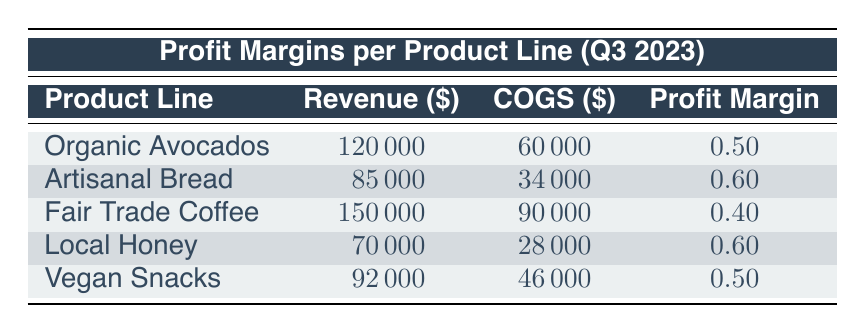What is the Profit Margin for Local Honey? The table shows that the Profit Margin for Local Honey is listed in the Profit Margin column next to its revenue and COGS data. It is 0.60.
Answer: 0.60 Which product line has the highest Revenue? Looking at the Revenue column, Fair Trade Coffee has the highest value of 150000, compared to others.
Answer: Fair Trade Coffee What is the combined Revenue of Organic Avocados and Artisanal Bread? To find the combined Revenue of Organic Avocados (120000) and Artisanal Bread (85000), add these amounts together: 120000 + 85000 = 205000.
Answer: 205000 Is the Profit Margin for Vegan Snacks greater than that of Fair Trade Coffee? The Profit Margin for Vegan Snacks is 0.50, while for Fair Trade Coffee it is 0.40. Since 0.50 is greater than 0.40, the answer is yes.
Answer: Yes What is the average Profit Margin for all product lines combined? To calculate the average Profit Margin, sum the Profit Margins for all products: (0.50 + 0.60 + 0.40 + 0.60 + 0.50) = 2.60. Since there are 5 product lines, divide by 5: 2.60 / 5 = 0.52.
Answer: 0.52 Does Artisanal Bread have a lower Profit Margin than Local Honey? Artisanal Bread's Profit Margin is 0.60, and Local Honey's Profit Margin is also 0.60. Since they are equal, the statement is false.
Answer: No Which product line has the lowest Profit Margin? Reviewing the Profit Margin column, Fair Trade Coffee has the lowest Profit Margin at 0.40 compared to others.
Answer: Fair Trade Coffee What is the total Cost of Goods Sold (COGS) for all product lines? To find the total COGS, add the COGS values: 60000 + 34000 + 90000 + 28000 + 46000 = 264000.
Answer: 264000 